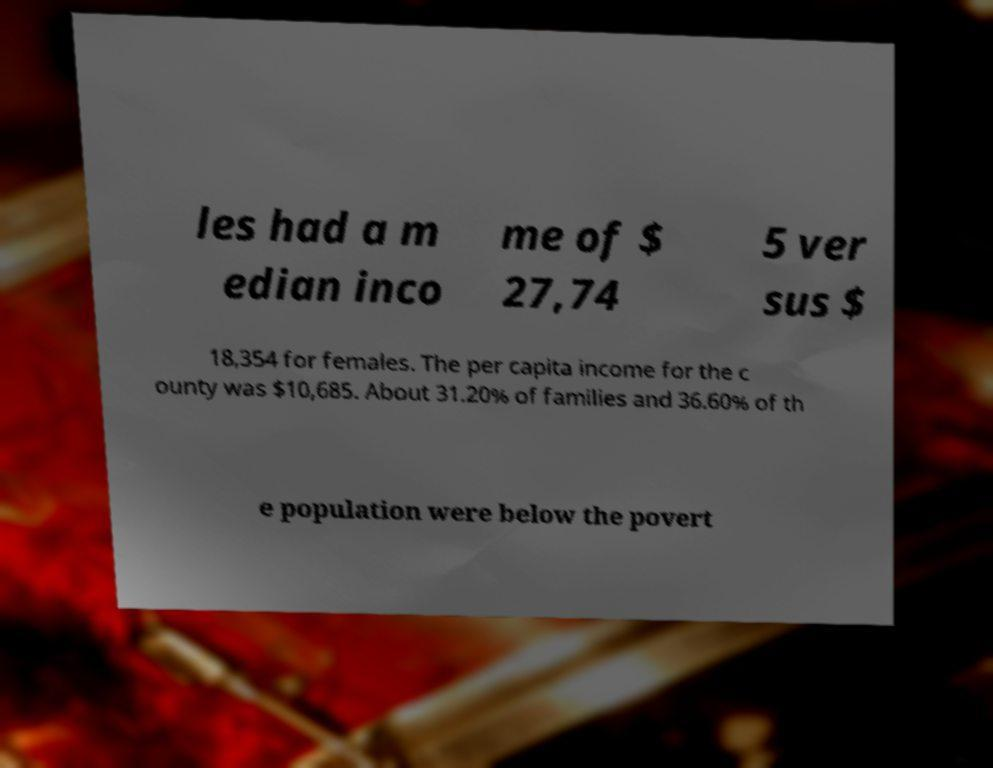There's text embedded in this image that I need extracted. Can you transcribe it verbatim? les had a m edian inco me of $ 27,74 5 ver sus $ 18,354 for females. The per capita income for the c ounty was $10,685. About 31.20% of families and 36.60% of th e population were below the povert 